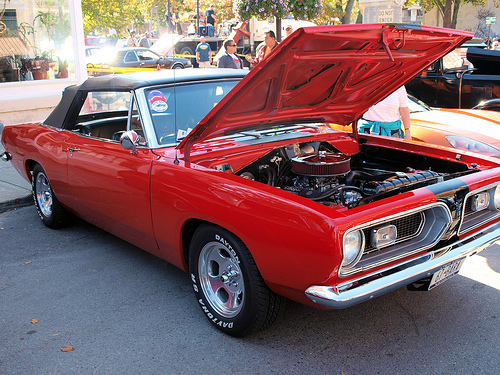<image>
Is there a sidewalk on the car? No. The sidewalk is not positioned on the car. They may be near each other, but the sidewalk is not supported by or resting on top of the car. 